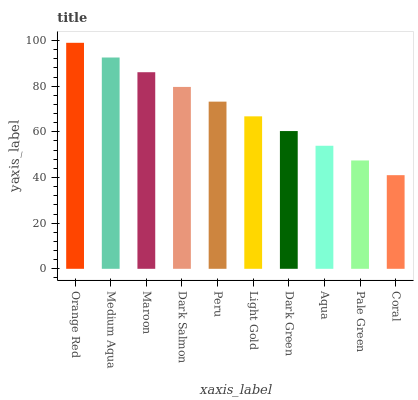Is Coral the minimum?
Answer yes or no. Yes. Is Orange Red the maximum?
Answer yes or no. Yes. Is Medium Aqua the minimum?
Answer yes or no. No. Is Medium Aqua the maximum?
Answer yes or no. No. Is Orange Red greater than Medium Aqua?
Answer yes or no. Yes. Is Medium Aqua less than Orange Red?
Answer yes or no. Yes. Is Medium Aqua greater than Orange Red?
Answer yes or no. No. Is Orange Red less than Medium Aqua?
Answer yes or no. No. Is Peru the high median?
Answer yes or no. Yes. Is Light Gold the low median?
Answer yes or no. Yes. Is Medium Aqua the high median?
Answer yes or no. No. Is Dark Green the low median?
Answer yes or no. No. 